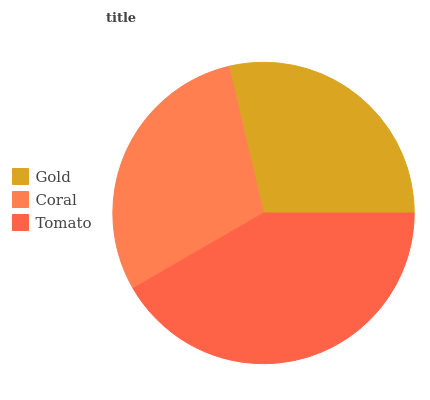Is Gold the minimum?
Answer yes or no. Yes. Is Tomato the maximum?
Answer yes or no. Yes. Is Coral the minimum?
Answer yes or no. No. Is Coral the maximum?
Answer yes or no. No. Is Coral greater than Gold?
Answer yes or no. Yes. Is Gold less than Coral?
Answer yes or no. Yes. Is Gold greater than Coral?
Answer yes or no. No. Is Coral less than Gold?
Answer yes or no. No. Is Coral the high median?
Answer yes or no. Yes. Is Coral the low median?
Answer yes or no. Yes. Is Tomato the high median?
Answer yes or no. No. Is Tomato the low median?
Answer yes or no. No. 